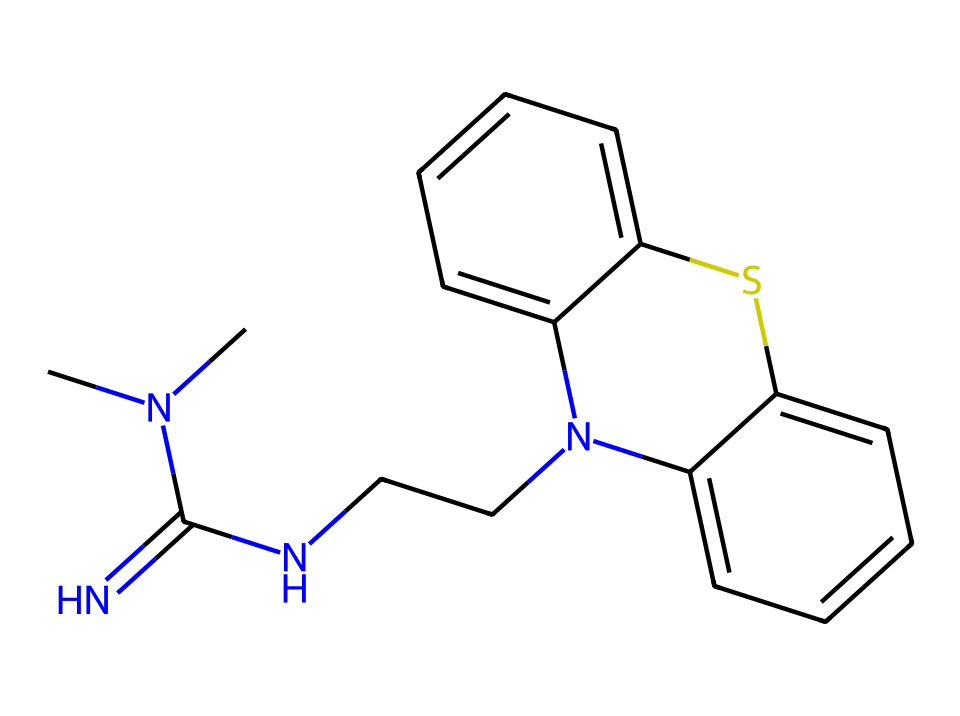What is the molecular formula of xylazine? To determine the molecular formula, we count the number of each type of atom present in the SMILES representation. For this compound, there are 17 carbon (C), 21 hydrogen (H), 4 nitrogen (N), and 1 sulfur (S) atom. The formula is C17H21N4S.
Answer: C17H21N4S How many nitrogen atoms are in xylazine? By examining the SMILES representation, I can count the nitrogen (N) symbols, which appear four times in the structure. Thus, there are four nitrogen atoms.
Answer: 4 What type of functional group is primarily present in xylazine? Analyzing the structure, the nitrogen atoms are involved in amine and imine functional groups due to their connections; xylazine is characterized primarily by amine due to multiple nitrogen attachments.
Answer: amine How many rings are present in the xylazine structure? The SMILES shows that there are two distinct cyclic structures indicated by "c" (which represents aromatic carbon rings). Tracking these, we find two rings in total in the xylazine molecule.
Answer: 2 What is the dominant structural feature of xylazine? The overall structure can be analyzed by focusing on the presence of a complex alkaloid arrangement characterized by fused benzene rings and several nitrogen centers affecting the pharmacological activity.
Answer: alkaloid Does the structure of xylazine indicate it is a polar or nonpolar molecule? To assess the polarity, we observe the presence of nitrogen atoms within amine functional groups; these lead to overall charge distribution, creating polar characteristics in the molecule. Thus, the structure suggests it is polar due to the nitrogen atoms.
Answer: polar 